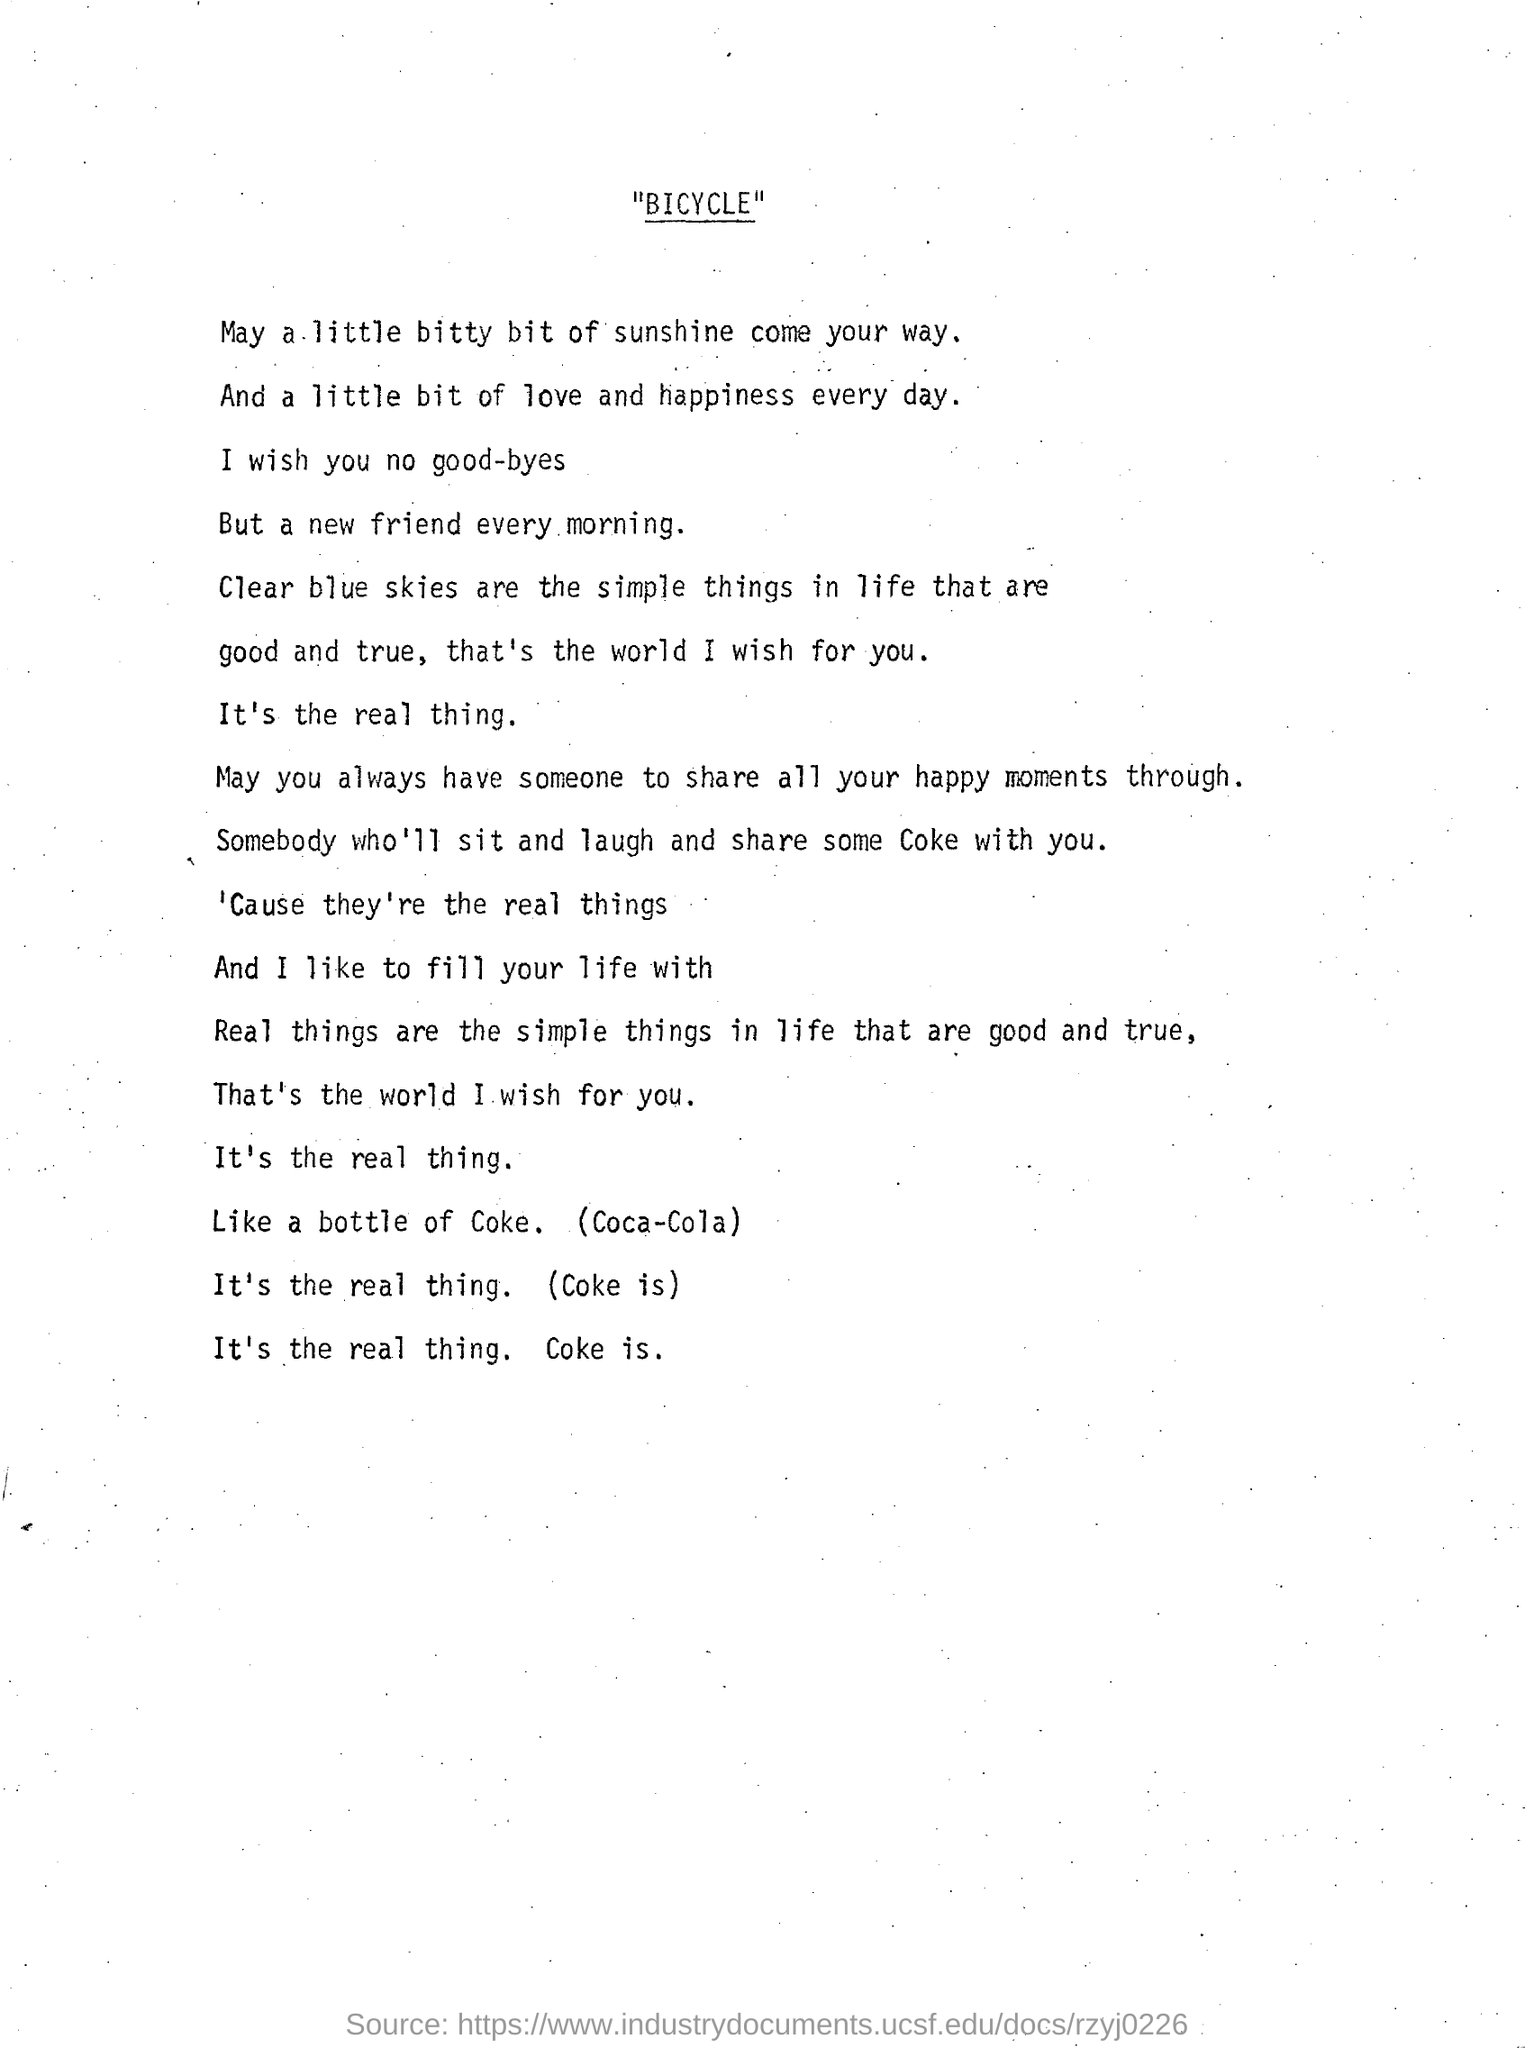Identify some key points in this picture. The title of this document is "BICYCLE". 